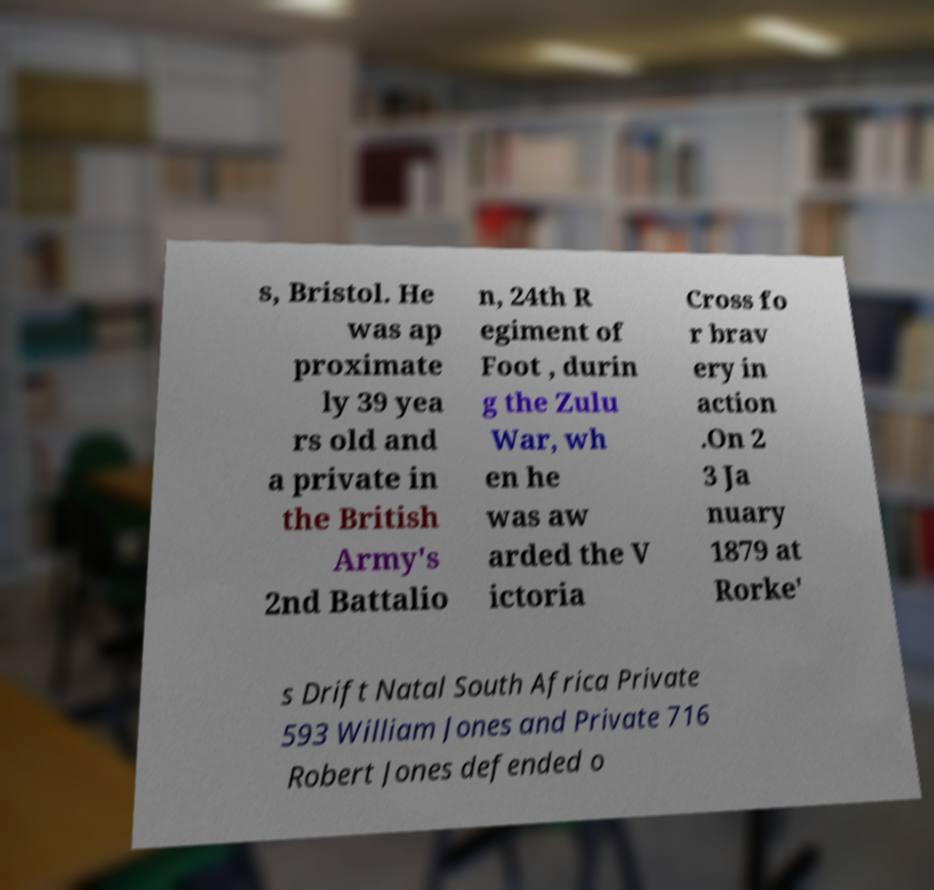There's text embedded in this image that I need extracted. Can you transcribe it verbatim? s, Bristol. He was ap proximate ly 39 yea rs old and a private in the British Army's 2nd Battalio n, 24th R egiment of Foot , durin g the Zulu War, wh en he was aw arded the V ictoria Cross fo r brav ery in action .On 2 3 Ja nuary 1879 at Rorke' s Drift Natal South Africa Private 593 William Jones and Private 716 Robert Jones defended o 